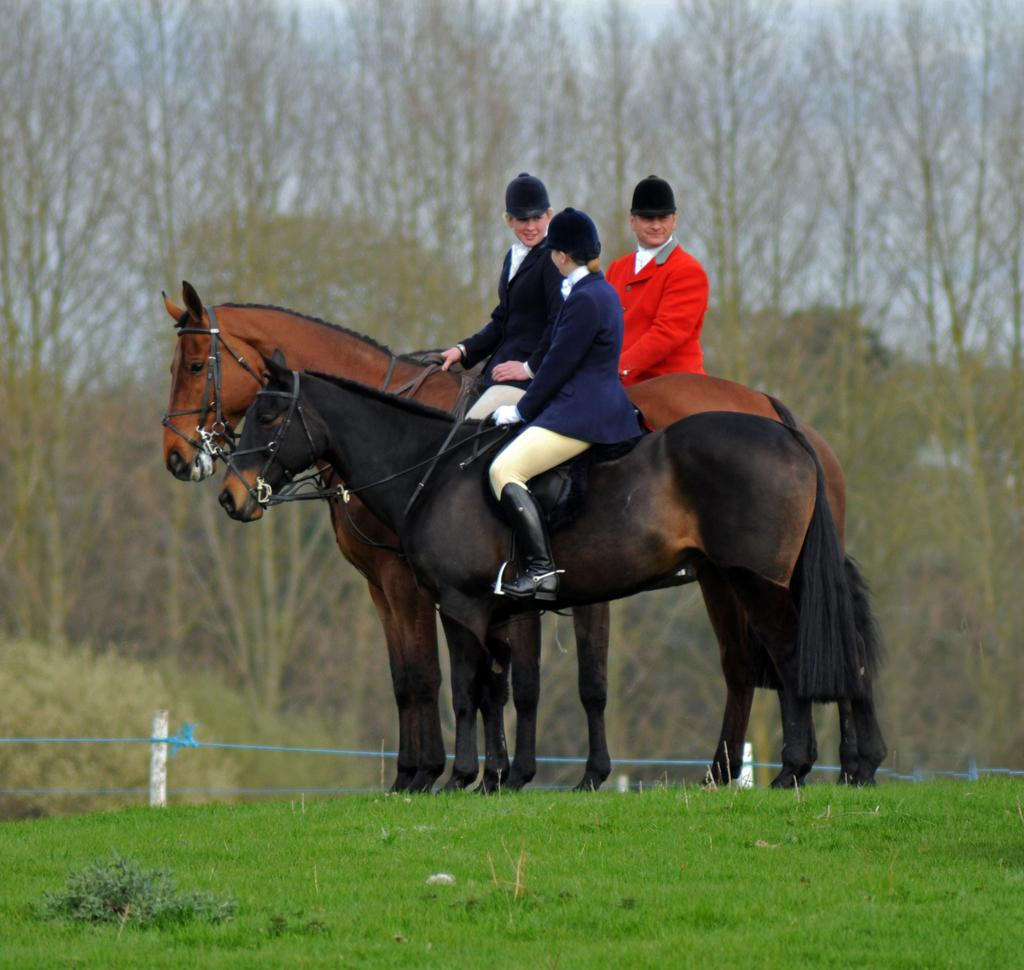How many people are in the image? There are three persons in the image. What are the persons doing in the image? The persons are riding horses. Where are the horses located in the image? The horses are on the ground. What can be seen in the background of the image? There is a fence, a pole, trees, and the sky visible in the background of the image. How many sheep are visible in the image? There are no sheep present in the image. What type of attraction can be seen in the image? There is no attraction present in the image; it features three persons riding horses. 